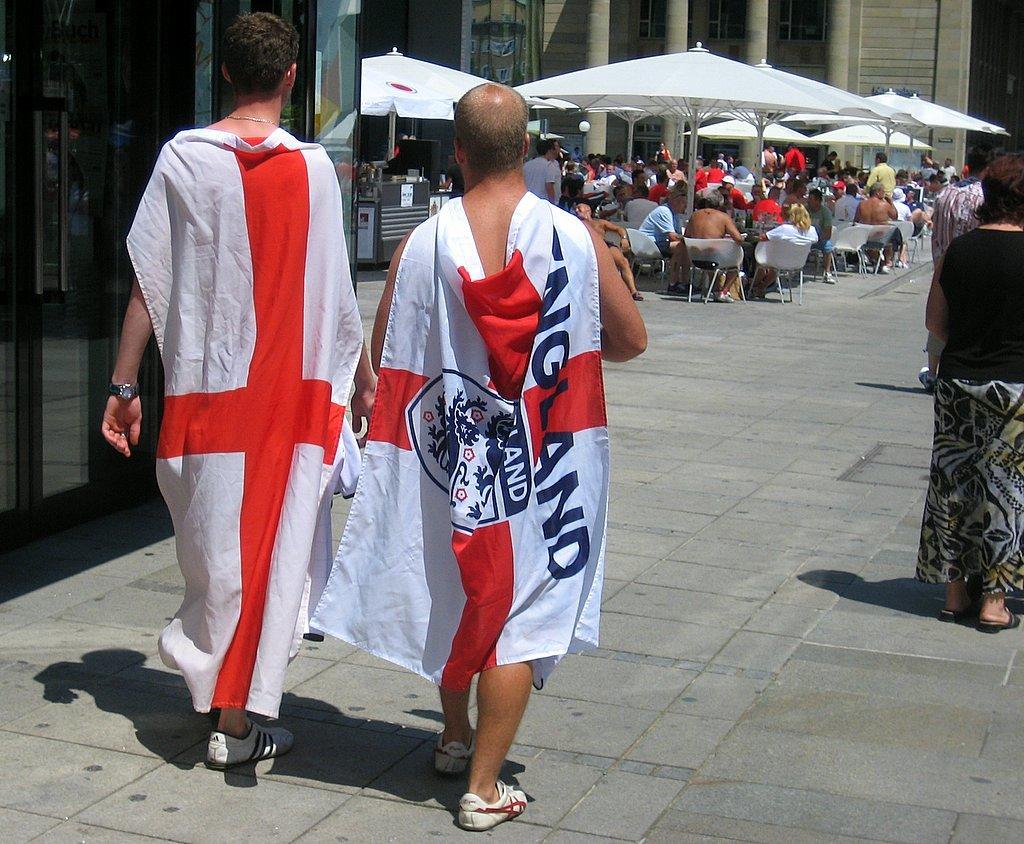What country is being represented by the man on the right's cape?
Ensure brevity in your answer.  England. 